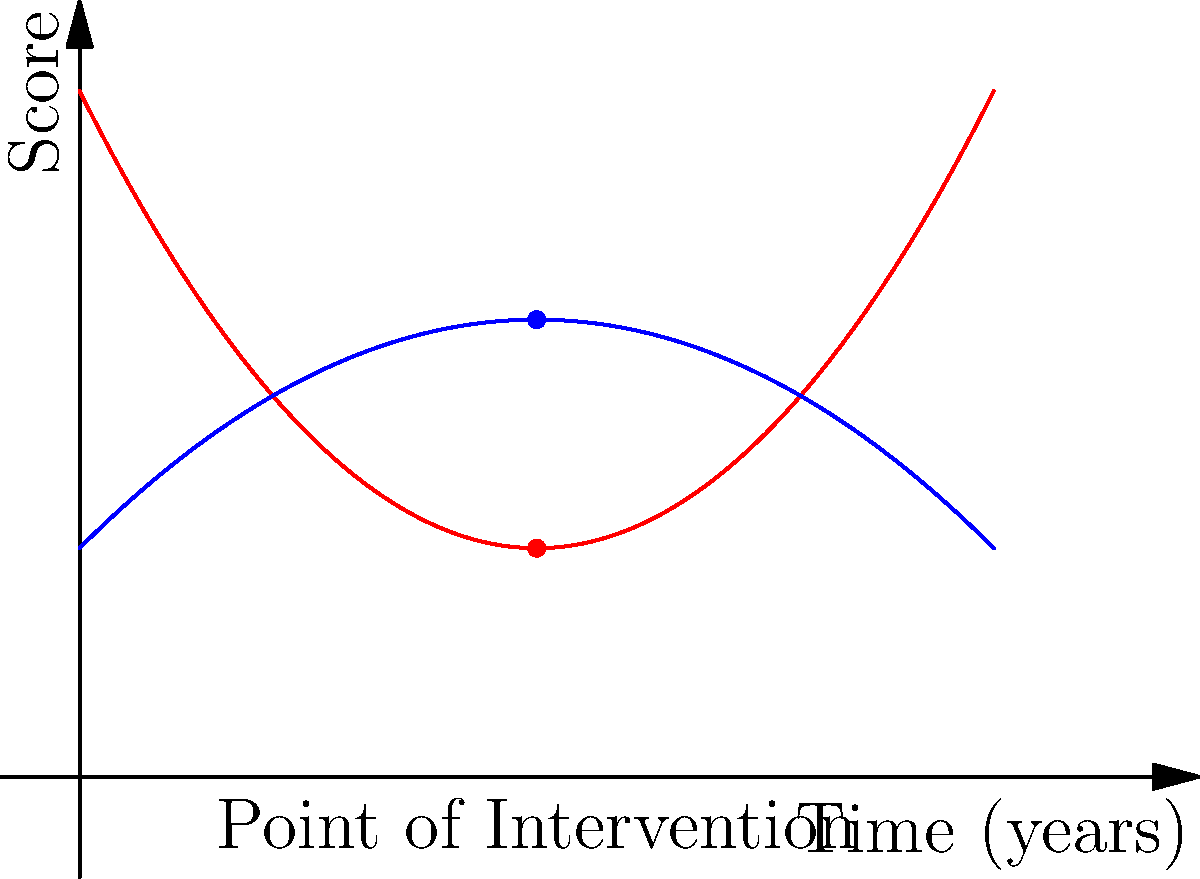A student's academic performance and mental health scores are tracked over time, represented by the red and blue curves respectively in the graph. At the point of intervention (2 years), what is the angle $\theta$ between the tangent vectors of these two curves, and what does this angle suggest about the relationship between academic performance and mental health at that moment? To find the angle between the tangent vectors, we need to follow these steps:

1) First, we need to find the derivatives of both functions at x = 2:

   For academic performance (red curve): $f(x) = 0.5x^2 - 2x + 3$
   $f'(x) = x - 2$
   At x = 2: $f'(2) = 2 - 2 = 0$

   For mental health (blue curve): $g(x) = -0.25x^2 + x + 1$
   $g'(x) = -0.5x + 1$
   At x = 2: $g'(2) = -1 + 1 = 0$

2) The tangent vectors at x = 2 are:
   $\vec{v}_1 = (1, 0)$ for academic performance
   $\vec{v}_2 = (1, 0)$ for mental health

3) The angle between these vectors can be calculated using the dot product formula:
   $\cos \theta = \frac{\vec{v}_1 \cdot \vec{v}_2}{|\vec{v}_1||\vec{v}_2|}$

4) Substituting the values:
   $\cos \theta = \frac{1 \cdot 1 + 0 \cdot 0}{\sqrt{1^2 + 0^2}\sqrt{1^2 + 0^2}} = \frac{1}{1} = 1$

5) Therefore, $\theta = \arccos(1) = 0°$

The angle of 0° suggests that at the point of intervention, the trajectories of academic performance and mental health are perfectly aligned, indicating a strong positive correlation between the two factors at that moment.
Answer: $0°$, indicating perfect alignment and strong positive correlation. 